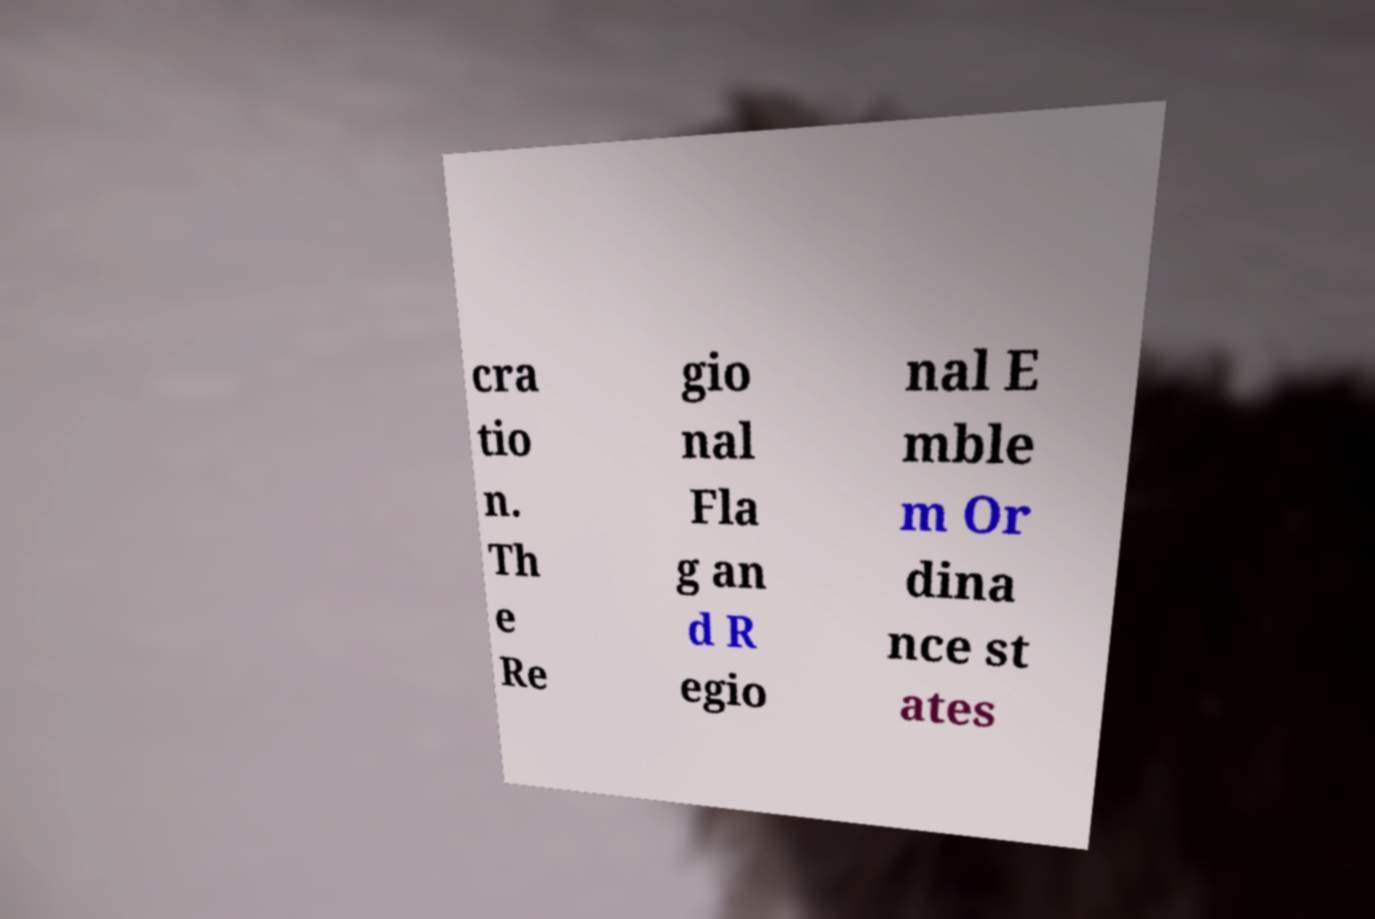Please read and relay the text visible in this image. What does it say? cra tio n. Th e Re gio nal Fla g an d R egio nal E mble m Or dina nce st ates 